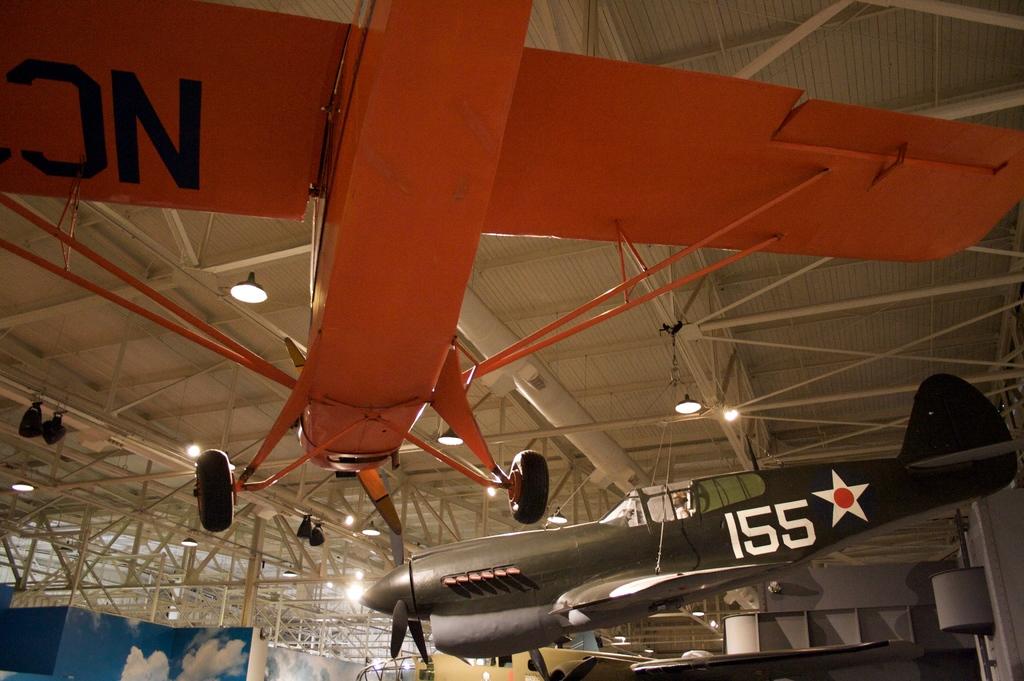What number is on the grey plane?
Provide a succinct answer. 155. What letters are on the orange plane?
Make the answer very short. Nc. 